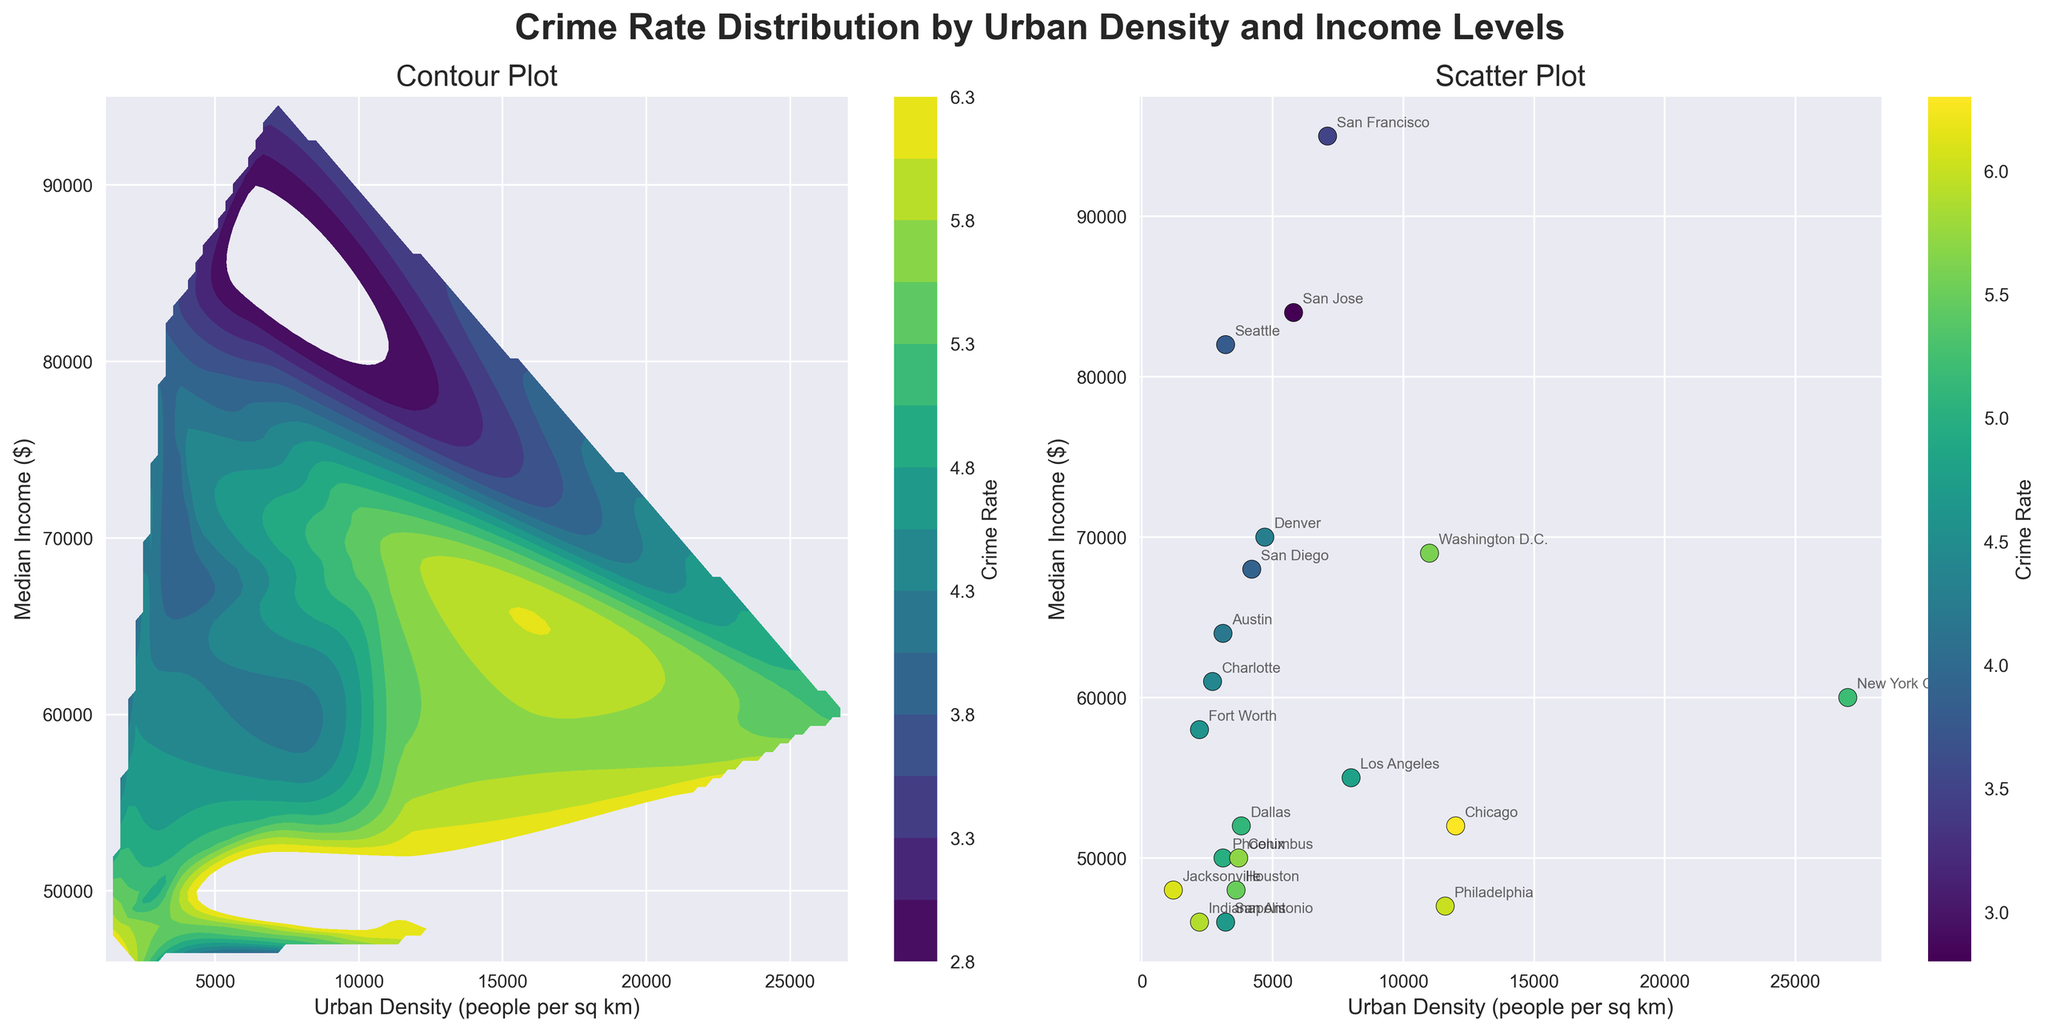What is the title of the figure? The title is displayed at the top of the figure, in bold and large font size. It is "Crime Rate Distribution by Urban Density and Income Levels".
Answer: Crime Rate Distribution by Urban Density and Income Levels What are the x and y axes labels in the contour plot? The x-axis label is positioned below the horizontal axis, and the y-axis label is positioned beside the vertical axis of the contour plot. They indicate the variables being plotted: 'Urban Density (people per sq km)' for the x-axis and 'Median Income ($)' for the y-axis.
Answer: Urban Density (people per sq km), Median Income ($) Which cities have the lowest crime rate according to the scatter plot? The cities with the lowest crime rate will be found by looking at the scatter plot and identifying the points with the lowest color intensity (based on the color bar).
Answer: San Francisco, San Jose How does crime rate vary with urban density and median income in the contour plot? The pattern is observed by examining the contour lines and color gradient in the contour plot, which show how z-values (crime rate) change with respect to x-values (urban density) and y-values (median income). Generally, areas with higher colors (higher crime rates) can be compared to those with lower colors.
Answer: Crime rate tends to be higher in medium-density, lower-income areas Which city has the highest crime rate and what are its urban density and median income levels? In the scatter plot, find the city with the highest crime rate color (according to the color bar). Look for the corresponding markers and city label. This city's data includes its urban density and median income levels.
Answer: Chicago; Urban Density: 12000, Median Income: 52000 What can be inferred about the relationship between the crime rate and urban density alone? By examining the scatter plot's horizontal distribution and the contour plot's trends along the x-axis (urban density), look for any general patterns correlating urban density and crime rate.
Answer: Higher urban density does not always correlate with a higher crime rate Identify the region with the highest crime rate in the contour plot. In the contour plot, the darkest (most intense) colored region corresponds to the highest crime rates. This region can then be described in terms of its x and y value ranges.
Answer: Medium-density, lower-income areas (around 10000-12000 density and <$55000 income) Which cities fall into the high crime rate region identified in the contour plot? Find the cities with data points within the highest crime rate regions as per the contour plot, matching urban density and median income closely to that region.
Answer: Chicago, Philadelphia What is the impact of higher median income on crime rates, according to the scatter plot? Examine how crime rates vary for high median income values by observing the position of higher-income cities and their corresponding crime rate colors in the scatter plot.
Answer: Generally, higher median income correlates with lower crime rates Is there a city with both low urban density and low crime rate? Analyze the scatter plot for a data point that is situated in the lower range of urban density and has a low crime rate color according to the color bar.
Answer: San Diego 